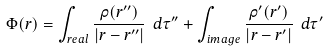Convert formula to latex. <formula><loc_0><loc_0><loc_500><loc_500>\Phi ( { r } ) = \int _ { r e a l } \frac { \rho ( { r ^ { \prime \prime } } ) } { | { r } - { r ^ { \prime \prime } | } } \ d \tau ^ { \prime \prime } + \int _ { i m a g e } \frac { \rho ^ { \prime } ( { r ^ { \prime } } ) } { | { r } - { r ^ { \prime } } | } \ d \tau ^ { \prime }</formula> 